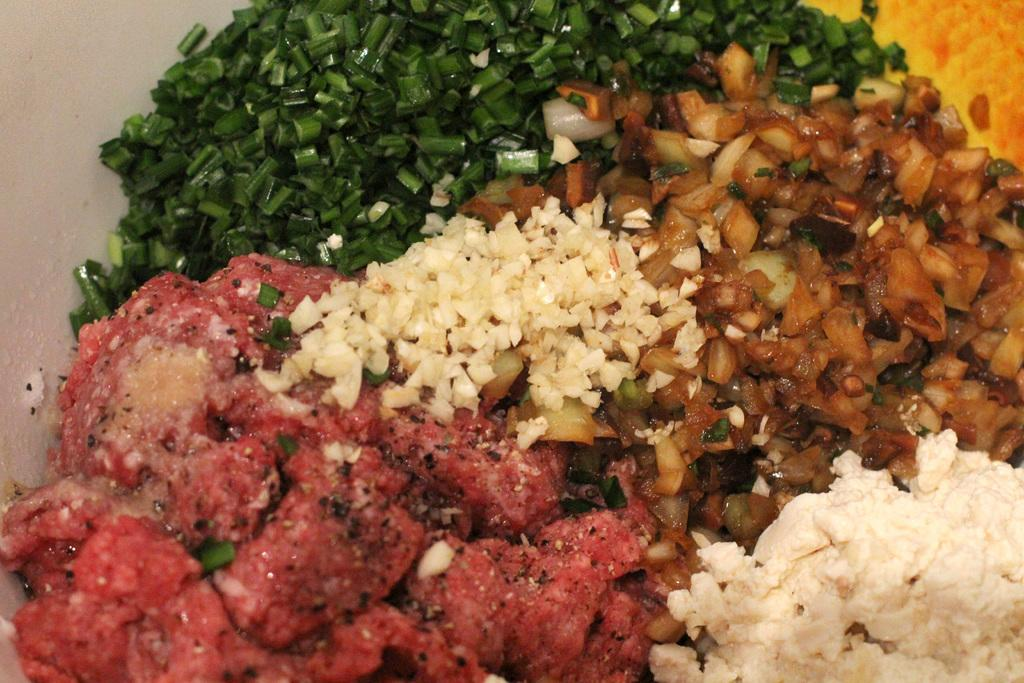What can be seen in the image? There is a group of food items in the image. Where are the food items located? The food items are on a platform. What type of milk is being regretted by the food items in the image? There is no milk or regret present in the image; it only features a group of food items on a platform. 